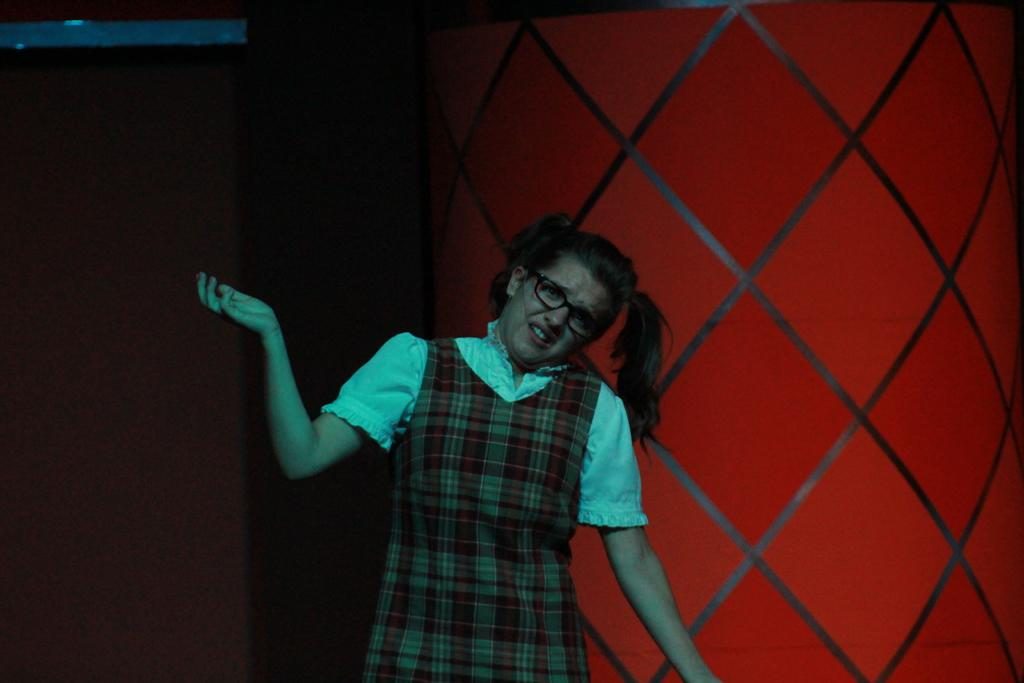Who is the main subject in the image? There is a woman in the image. What is the woman doing in the image? The woman is standing. What is the woman wearing on her upper body? The woman is wearing a white shirt. What accessory is the woman wearing on her face? The woman is wearing spectacles. What type of cork can be seen in the woman's shirt in the image? There is no cork present in the image, and the woman's shirt is white, not made of cork. 